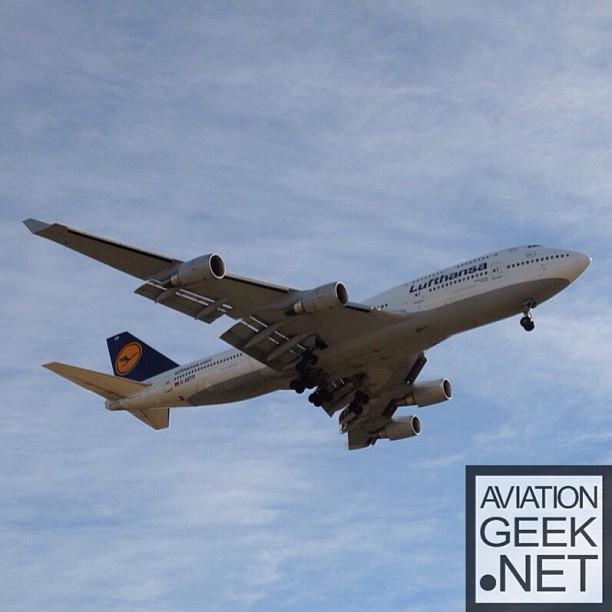How many engines are on this vehicle?
Give a very brief answer. 4. 